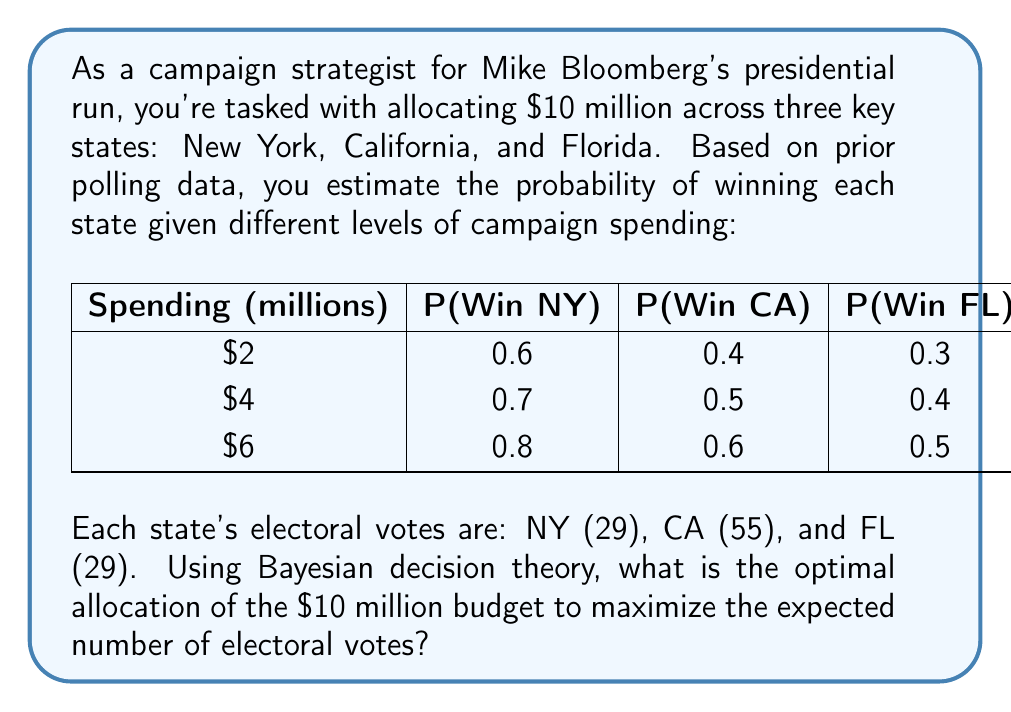Could you help me with this problem? To solve this problem using Bayesian decision theory, we need to calculate the expected utility (in this case, expected electoral votes) for each possible allocation and choose the one that maximizes it.

Step 1: Identify possible allocations
Given the $10 million budget and the spending options, we have these possible allocations:
1. NY($6M), CA($2M), FL($2M)
2. NY($4M), CA($4M), FL($2M)
3. NY($4M), CA($2M), FL($4M)
4. NY($2M), CA($6M), FL($2M)
5. NY($2M), CA($4M), FL($4M)

Step 2: Calculate expected utility for each allocation
For each allocation, we multiply the probability of winning each state by its electoral votes and sum the results.

1. NY($6M), CA($2M), FL($2M):
   $E(U) = 0.8 \cdot 29 + 0.4 \cdot 55 + 0.3 \cdot 29 = 23.2 + 22 + 8.7 = 53.9$

2. NY($4M), CA($4M), FL($2M):
   $E(U) = 0.7 \cdot 29 + 0.5 \cdot 55 + 0.3 \cdot 29 = 20.3 + 27.5 + 8.7 = 56.5$

3. NY($4M), CA($2M), FL($4M):
   $E(U) = 0.7 \cdot 29 + 0.4 \cdot 55 + 0.4 \cdot 29 = 20.3 + 22 + 11.6 = 53.9$

4. NY($2M), CA($6M), FL($2M):
   $E(U) = 0.6 \cdot 29 + 0.6 \cdot 55 + 0.3 \cdot 29 = 17.4 + 33 + 8.7 = 59.1$

5. NY($2M), CA($4M), FL($4M):
   $E(U) = 0.6 \cdot 29 + 0.5 \cdot 55 + 0.4 \cdot 29 = 17.4 + 27.5 + 11.6 = 56.5$

Step 3: Choose the allocation with the highest expected utility
The allocation that maximizes the expected number of electoral votes is NY($2M), CA($6M), FL($2M), with an expected utility of 59.1 electoral votes.
Answer: The optimal allocation is: New York ($2 million), California ($6 million), Florida ($2 million), which yields an expected 59.1 electoral votes. 